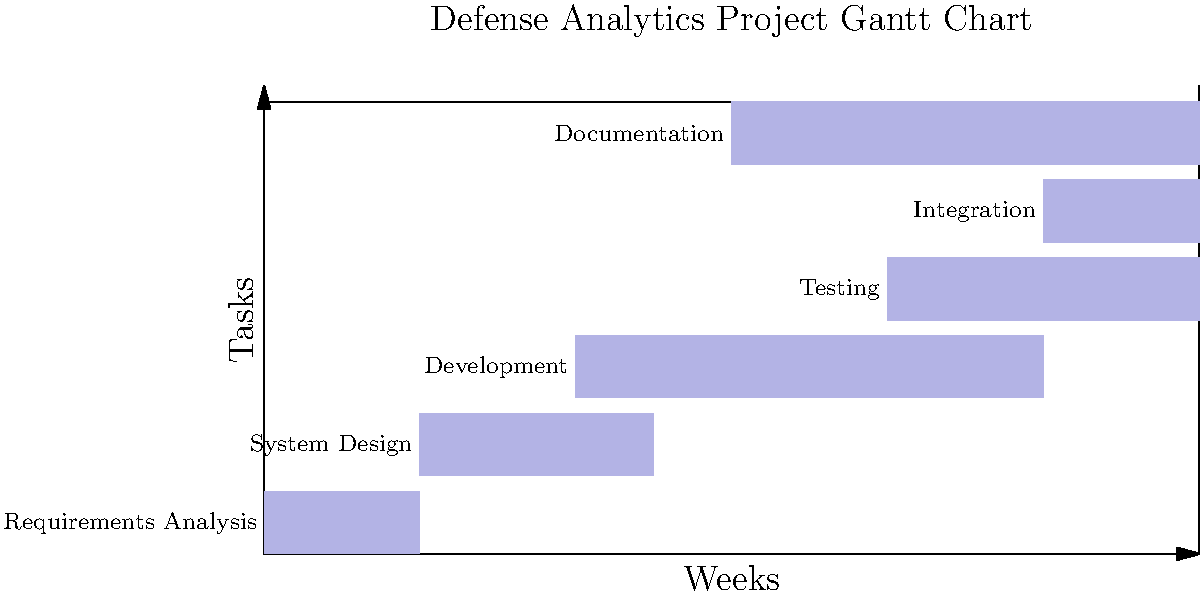Based on the Gantt chart for a defense analytics project, which task has the longest duration, and how does its timing impact the overall project timeline? To answer this question, we need to analyze the Gantt chart and follow these steps:

1. Identify the task durations:
   - Requirements Analysis: 2 weeks
   - System Design: 3 weeks
   - Development: 6 weeks
   - Testing: 4 weeks
   - Integration: 2 weeks
   - Documentation: 6 weeks

2. Determine the longest task:
   The longest tasks are Development and Documentation, both lasting 6 weeks.

3. Analyze the timing of these tasks:
   - Development starts at week 4 and ends at week 10
   - Documentation starts at week 6 and ends at week 12

4. Evaluate the impact on the project timeline:
   - Development is on the critical path, as Testing and Integration depend on its completion
   - Documentation runs parallel to Development, Testing, and Integration
   - The project's end is determined by the latest finishing task, which is Documentation at week 12

5. Consider the implications:
   - Any delay in Development could directly impact the project end date
   - Documentation, while equally long, has some flexibility as it runs parallel to other tasks

Therefore, while both Development and Documentation have the longest duration, Development has a more significant impact on the overall project timeline due to its position in the sequence of tasks and its influence on subsequent activities.
Answer: Development (6 weeks); critical path position affects subsequent tasks and potential project end date. 